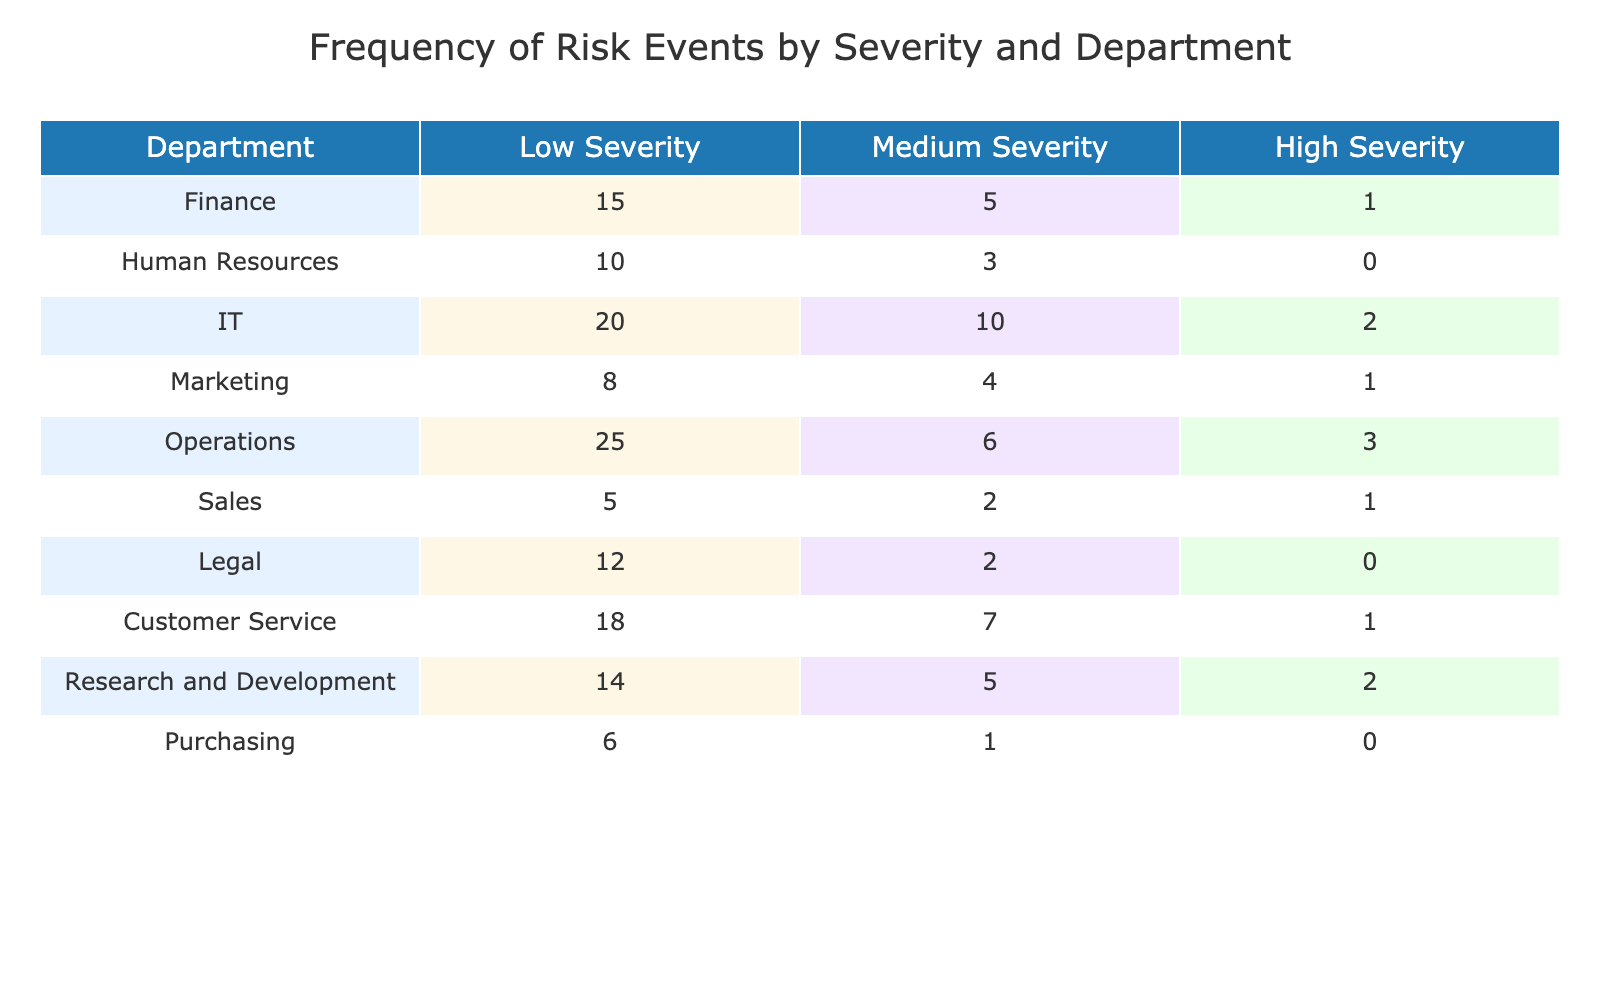What department has the highest frequency of low severity risk events? The table shows that the Operations department reports 25 low severity risk events, which is the highest among all departments.
Answer: Operations What is the total number of medium severity risk events across all departments? To find the total number of medium severity risk events, I add the counts from each department: 5 (Finance) + 3 (HR) + 10 (IT) + 4 (Marketing) + 6 (Operations) + 2 (Sales) + 2 (Legal) + 7 (Customer Service) + 5 (R&D) + 1 (Purchasing) = 45.
Answer: 45 Does the Customer Service department have more high severity risk events than the Human Resources department? The Customer Service department has 1 high severity risk event while the Human Resources department has 0. Since 1 is greater than 0, the answer is yes.
Answer: Yes What is the difference in the number of low severity risk events between the IT and Legal departments? The IT department has 20 low severity risk events while the Legal department has 12. To find the difference, I subtract: 20 - 12 = 8.
Answer: 8 What is the average number of high severity risk events across all departments? There are 10 entries in total for high severity risk events: 1 (Finance) + 0 (HR) + 2 (IT) + 1 (Marketing) + 3 (Operations) + 1 (Sales) + 0 (Legal) + 1 (Customer Service) + 2 (R&D) + 0 (Purchasing) = 10. Since there are 10 departments, the average is 10 / 10 = 1.
Answer: 1 Which department reports the least number of risk events across all severities? By adding up the risk events for each department: Finance (21), HR (13), IT (32), Marketing (13), Operations (34), Sales (8), Legal (14), Customer Service (26), R&D (21), Purchasing (7), the Purchasing department has the least total at 7.
Answer: Purchasing Is the total number of high severity events greater than 5? There are a total of 10 high severity risk events calculated previously. Since 10 is greater than 5, the answer is yes.
Answer: Yes What is the combined total of low severity risk events for the Sales and Marketing departments? The Sales department has 5 low severity events and the Marketing department has 8. Combining these gives: 5 + 8 = 13.
Answer: 13 